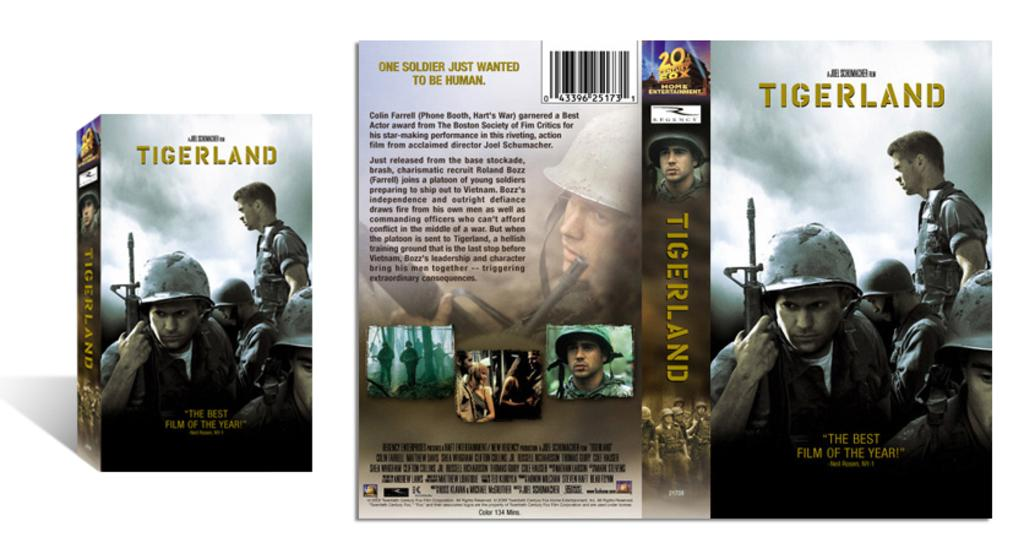<image>
Share a concise interpretation of the image provided. The outside of the case for the movie Tigerland. 